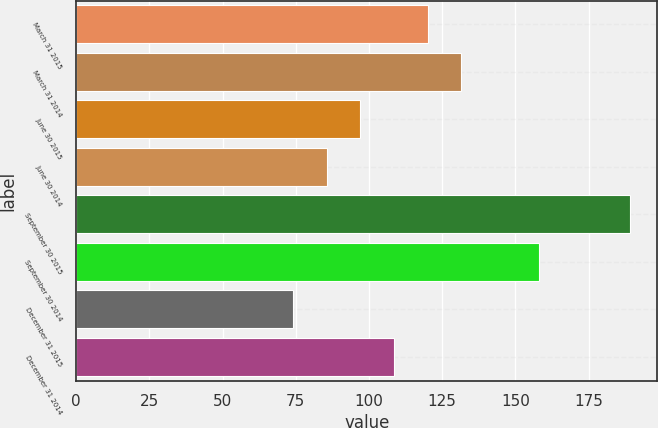<chart> <loc_0><loc_0><loc_500><loc_500><bar_chart><fcel>March 31 2015<fcel>March 31 2014<fcel>June 30 2015<fcel>June 30 2014<fcel>September 30 2015<fcel>September 30 2014<fcel>December 31 2015<fcel>December 31 2014<nl><fcel>120<fcel>131.5<fcel>97<fcel>85.5<fcel>189<fcel>158<fcel>74<fcel>108.5<nl></chart> 